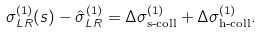<formula> <loc_0><loc_0><loc_500><loc_500>\sigma _ { L R } ^ { ( 1 ) } ( s ) - \hat { \sigma } ^ { ( 1 ) } _ { L R } = \Delta \sigma _ { \text {s-coll} } ^ { ( 1 ) } + \Delta \sigma _ { \text {h-coll} } ^ { ( 1 ) } .</formula> 